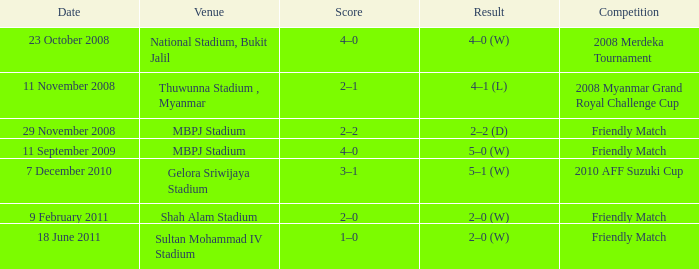Which contest resulted in a 2-0 score? Friendly Match. 